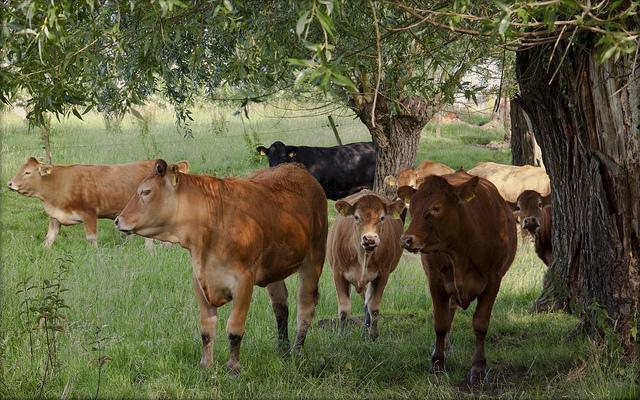What is the young offspring of these animals called?
Make your selection from the four choices given to correctly answer the question.
Options: Kitten, calf, joey, doe. Calf. 